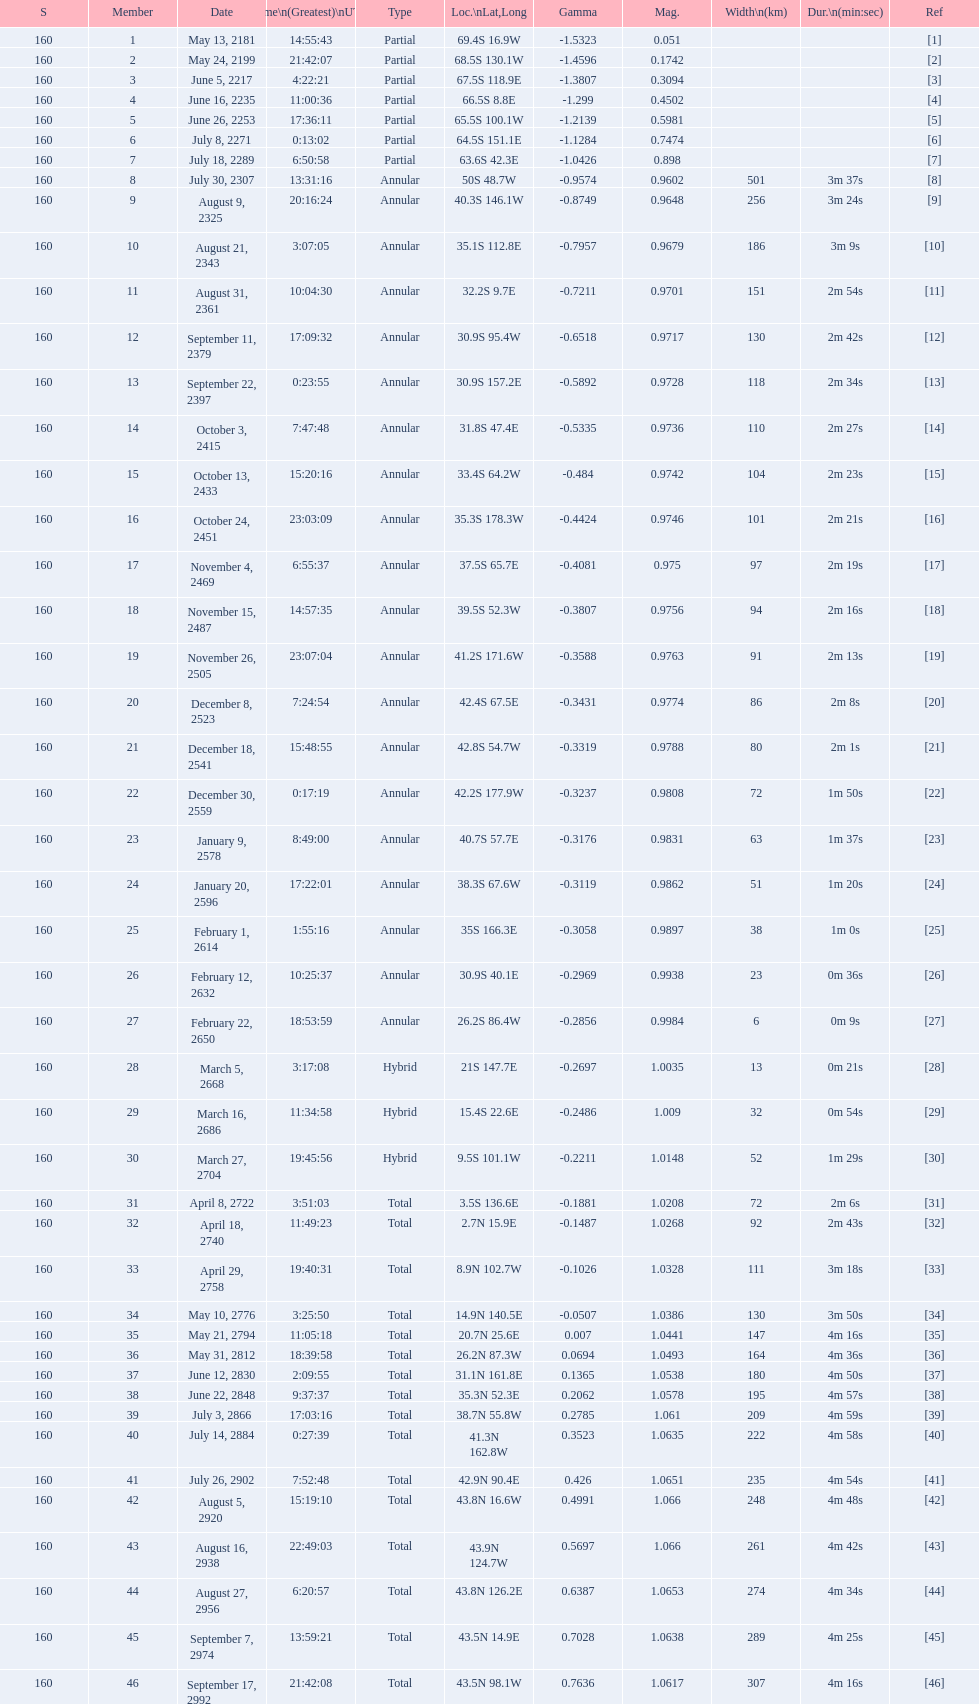How many total events will occur in all? 46. 